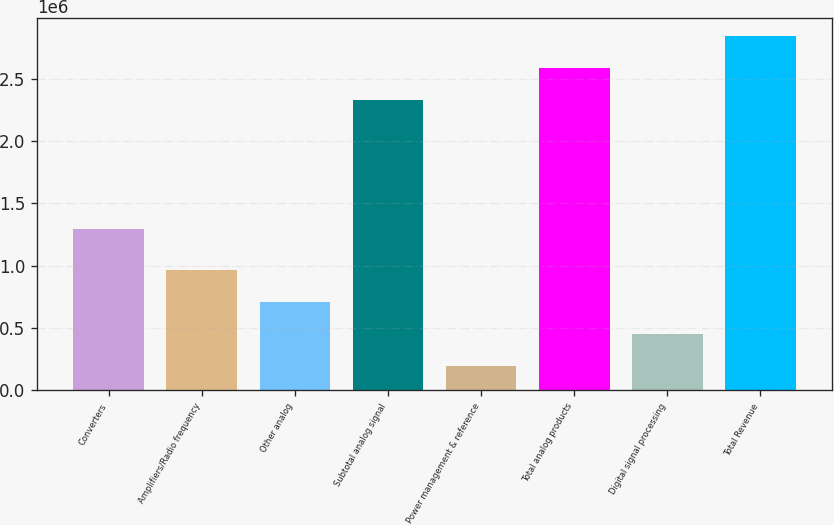Convert chart to OTSL. <chart><loc_0><loc_0><loc_500><loc_500><bar_chart><fcel>Converters<fcel>Amplifiers/Radio frequency<fcel>Other analog<fcel>Subtotal analog signal<fcel>Power management & reference<fcel>Total analog products<fcel>Digital signal processing<fcel>Total Revenue<nl><fcel>1.2957e+06<fcel>964769<fcel>708093<fcel>2.33192e+06<fcel>194740<fcel>2.5886e+06<fcel>451416<fcel>2.84527e+06<nl></chart> 